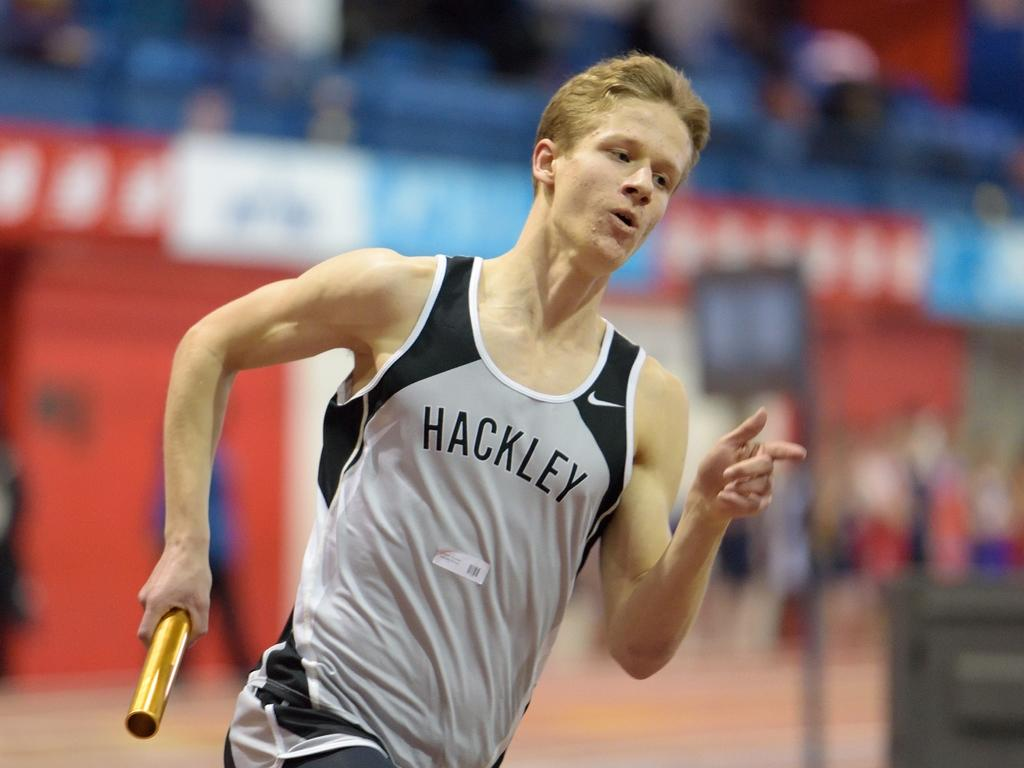<image>
Present a compact description of the photo's key features. the word Hackley is on the shirt of the man 